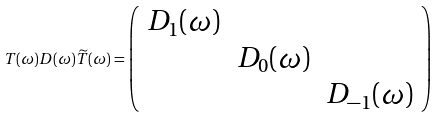<formula> <loc_0><loc_0><loc_500><loc_500>T ( \omega ) D ( \omega ) \widetilde { T } ( \omega ) = \left ( \begin{array} { c c c } D _ { 1 } ( \omega ) & & \\ & D _ { 0 } ( \omega ) & \\ & & D _ { - 1 } ( \omega ) \end{array} \right )</formula> 